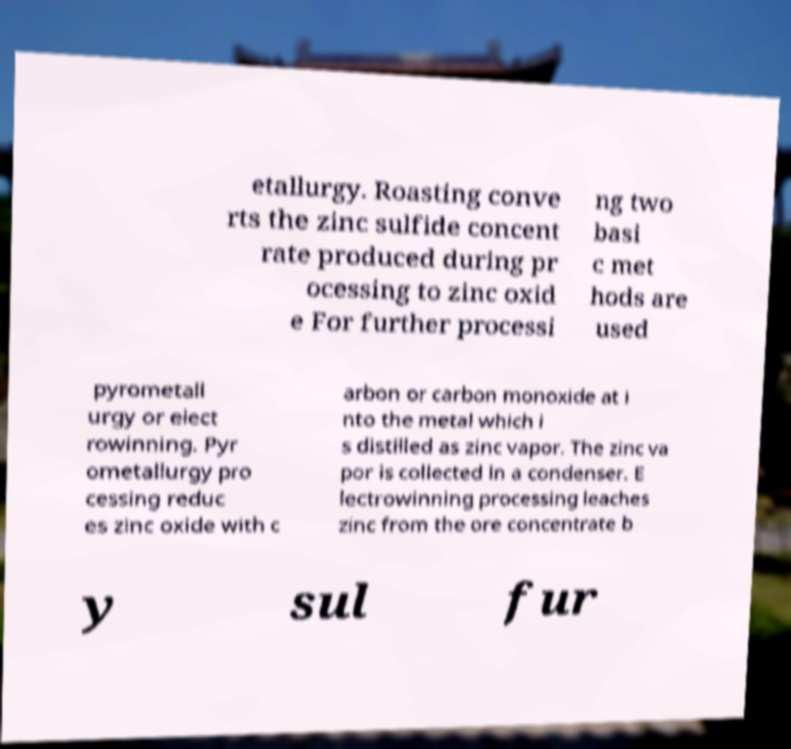There's text embedded in this image that I need extracted. Can you transcribe it verbatim? etallurgy. Roasting conve rts the zinc sulfide concent rate produced during pr ocessing to zinc oxid e For further processi ng two basi c met hods are used pyrometall urgy or elect rowinning. Pyr ometallurgy pro cessing reduc es zinc oxide with c arbon or carbon monoxide at i nto the metal which i s distilled as zinc vapor. The zinc va por is collected in a condenser. E lectrowinning processing leaches zinc from the ore concentrate b y sul fur 